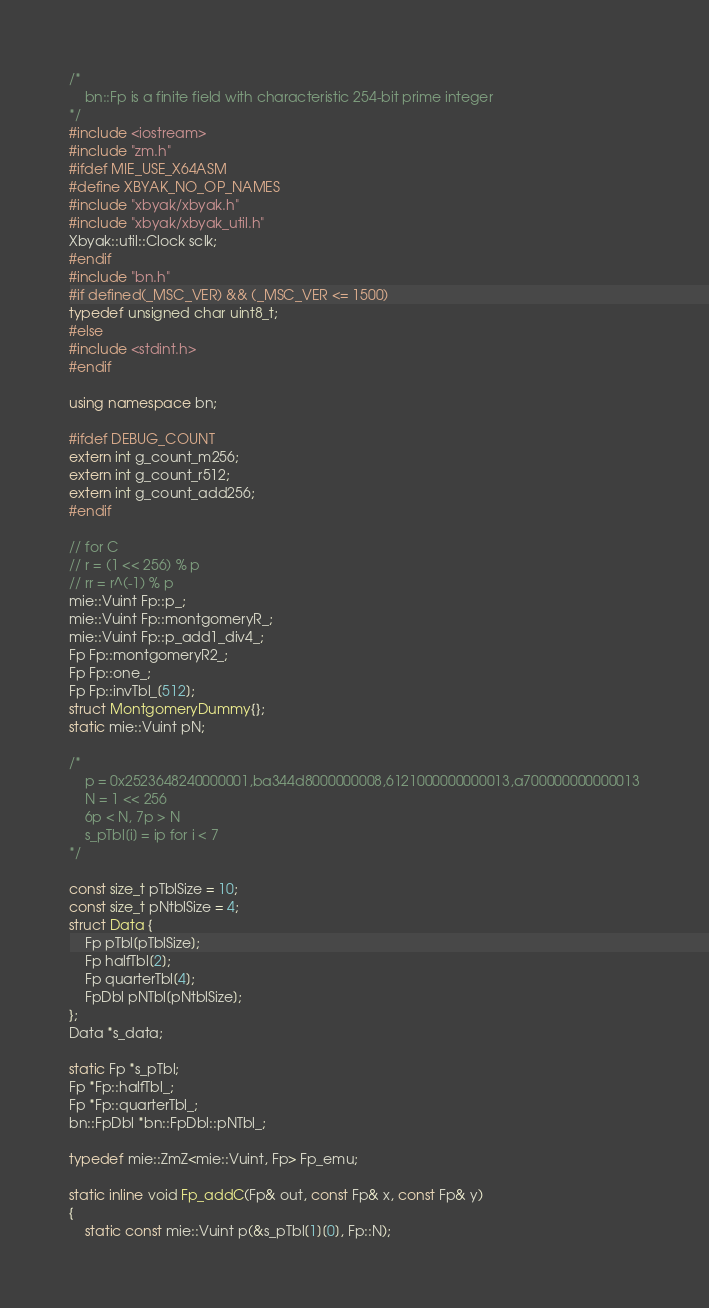Convert code to text. <code><loc_0><loc_0><loc_500><loc_500><_C++_>/*
	bn::Fp is a finite field with characteristic 254-bit prime integer
*/
#include <iostream>
#include "zm.h"
#ifdef MIE_USE_X64ASM
#define XBYAK_NO_OP_NAMES
#include "xbyak/xbyak.h"
#include "xbyak/xbyak_util.h"
Xbyak::util::Clock sclk;
#endif
#include "bn.h"
#if defined(_MSC_VER) && (_MSC_VER <= 1500)
typedef unsigned char uint8_t;
#else
#include <stdint.h>
#endif

using namespace bn;

#ifdef DEBUG_COUNT
extern int g_count_m256;
extern int g_count_r512;
extern int g_count_add256;
#endif

// for C
// r = (1 << 256) % p
// rr = r^(-1) % p
mie::Vuint Fp::p_;
mie::Vuint Fp::montgomeryR_;
mie::Vuint Fp::p_add1_div4_;
Fp Fp::montgomeryR2_;
Fp Fp::one_;
Fp Fp::invTbl_[512];
struct MontgomeryDummy{};
static mie::Vuint pN;

/*
	p = 0x2523648240000001,ba344d8000000008,6121000000000013,a700000000000013
	N = 1 << 256
	6p < N, 7p > N
	s_pTbl[i] = ip for i < 7
*/

const size_t pTblSize = 10;
const size_t pNtblSize = 4;
struct Data {
	Fp pTbl[pTblSize];
	Fp halfTbl[2];
	Fp quarterTbl[4];
	FpDbl pNTbl[pNtblSize];
};
Data *s_data;

static Fp *s_pTbl;
Fp *Fp::halfTbl_;
Fp *Fp::quarterTbl_;
bn::FpDbl *bn::FpDbl::pNTbl_;

typedef mie::ZmZ<mie::Vuint, Fp> Fp_emu;

static inline void Fp_addC(Fp& out, const Fp& x, const Fp& y)
{
	static const mie::Vuint p(&s_pTbl[1][0], Fp::N);</code> 